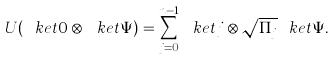Convert formula to latex. <formula><loc_0><loc_0><loc_500><loc_500>U ( \ k e t { 0 } \otimes \ k e t { \Psi } ) = \sum _ { j = 0 } ^ { n - 1 } \ k e t { j } \otimes \sqrt { \Pi _ { j } } \ k e t { \Psi } .</formula> 